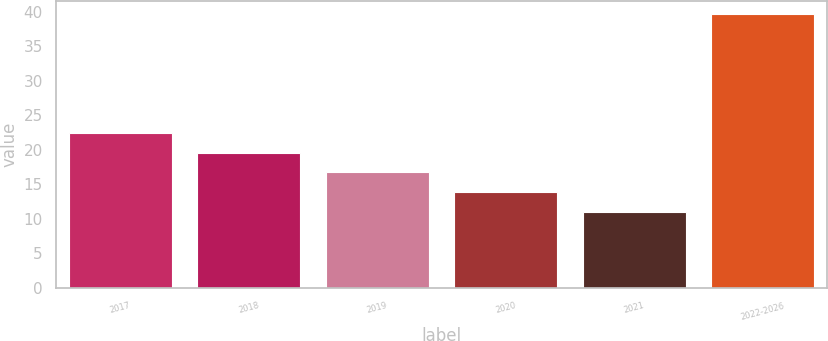<chart> <loc_0><loc_0><loc_500><loc_500><bar_chart><fcel>2017<fcel>2018<fcel>2019<fcel>2020<fcel>2021<fcel>2022-2026<nl><fcel>22.44<fcel>19.58<fcel>16.72<fcel>13.86<fcel>11<fcel>39.6<nl></chart> 